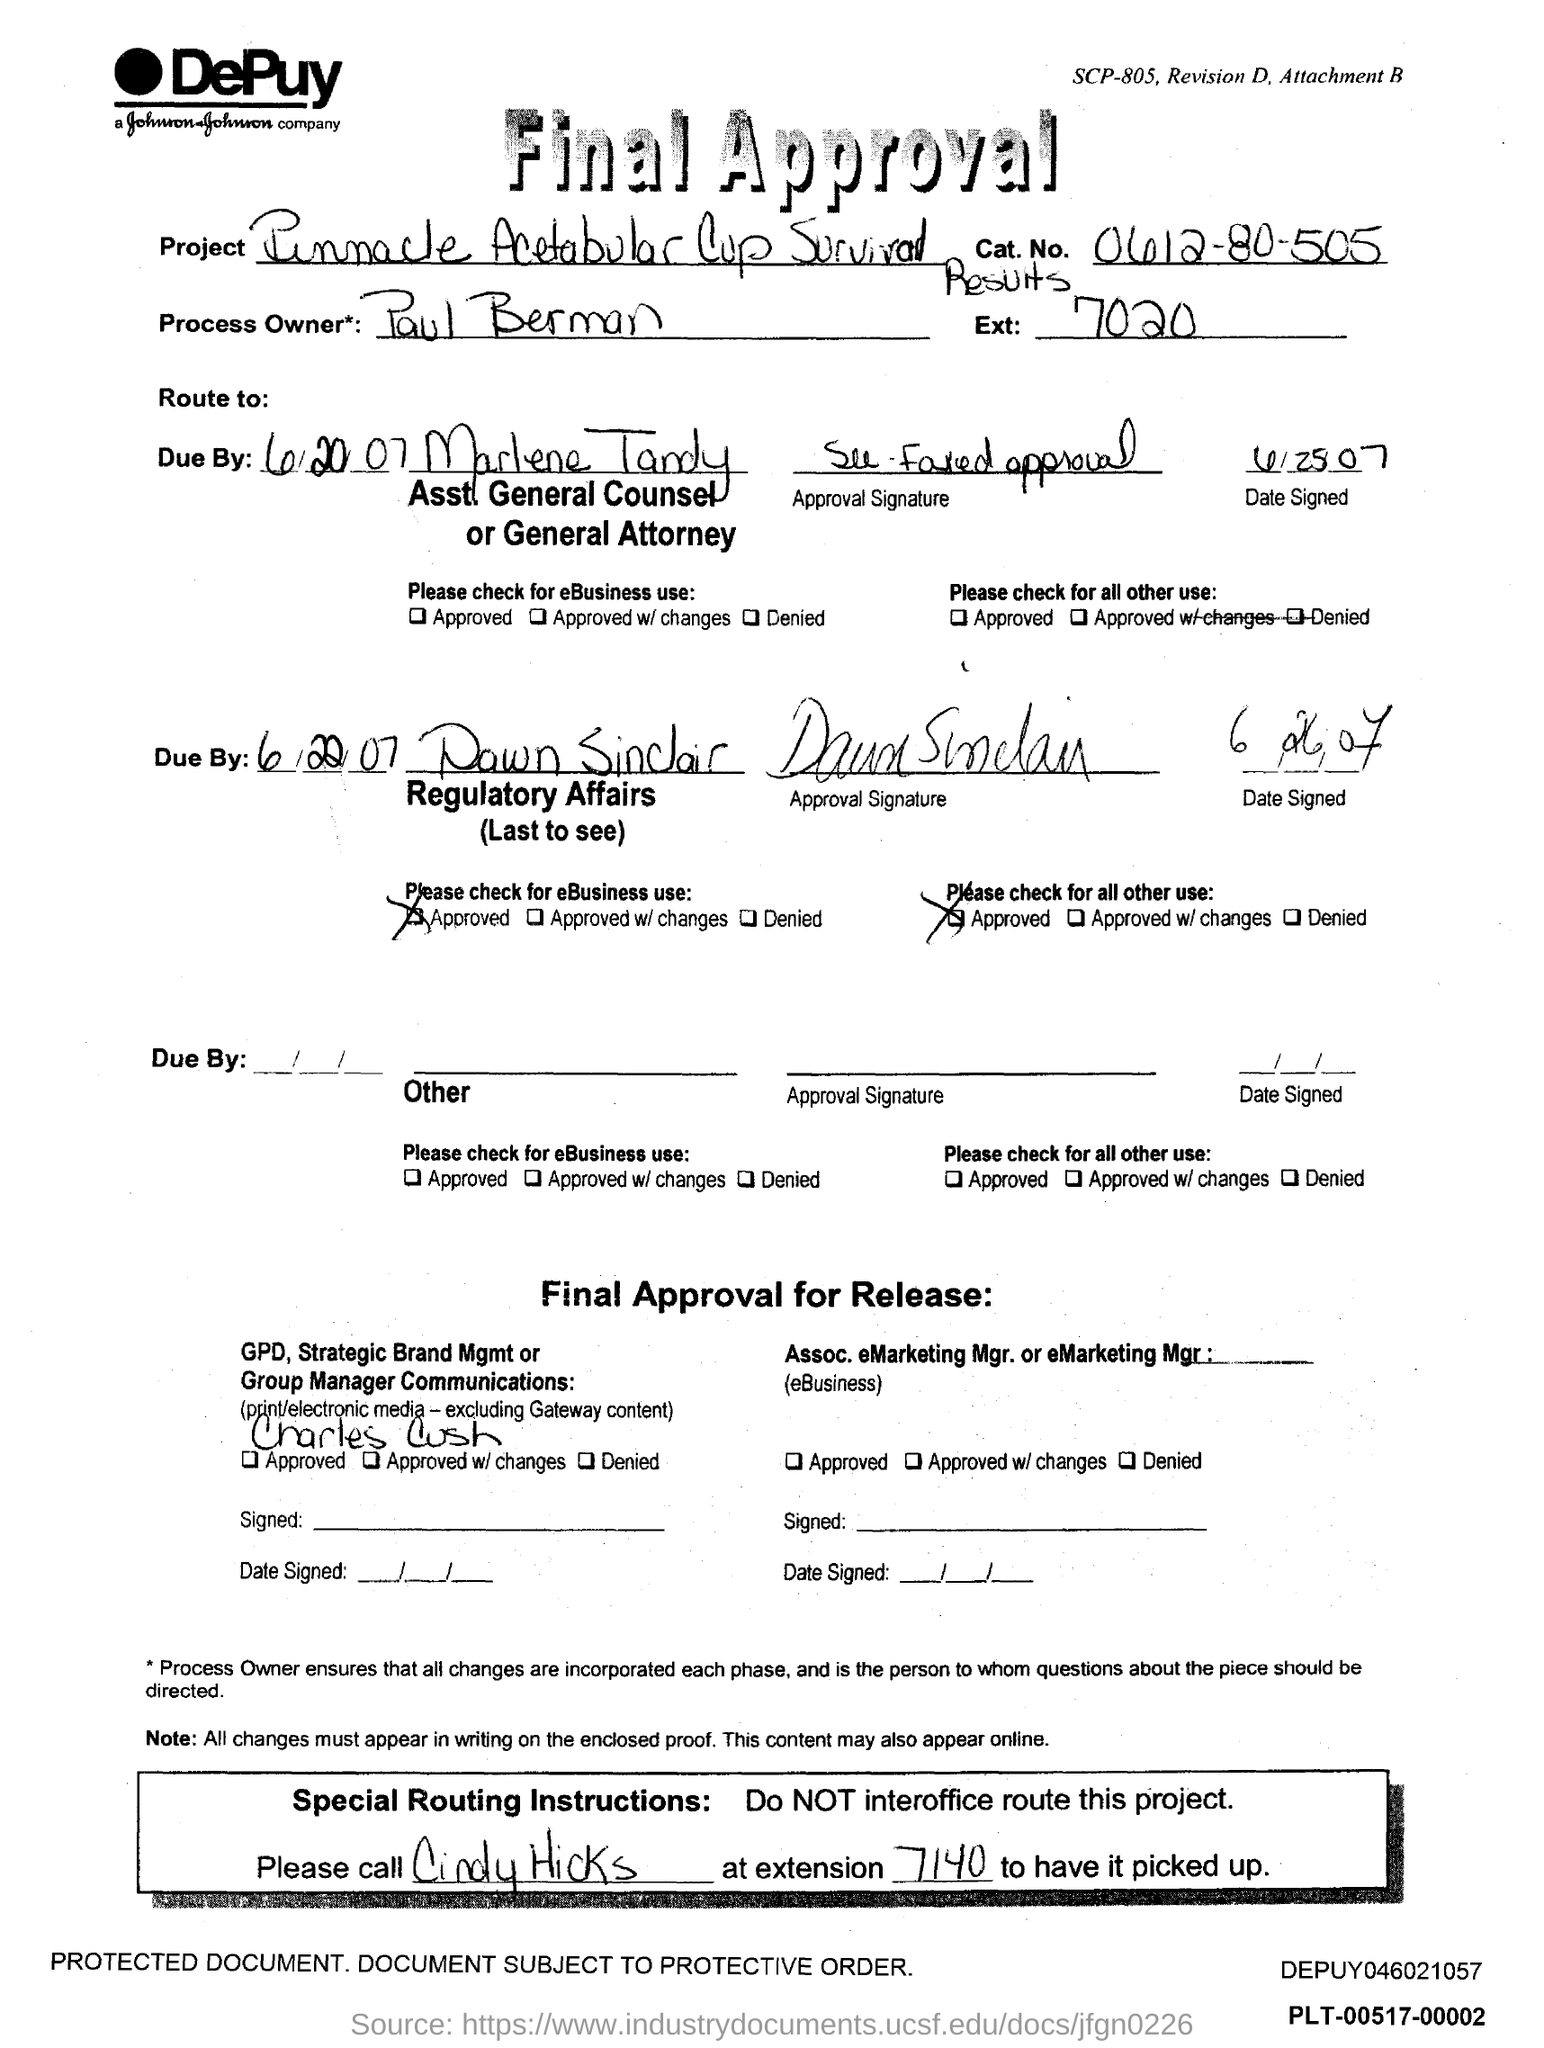Draw attention to some important aspects in this diagram. Paul Berman is the process owner. What is the catalog number for the item? 0612-80-505... Please provide the extension number, which is 7020... 